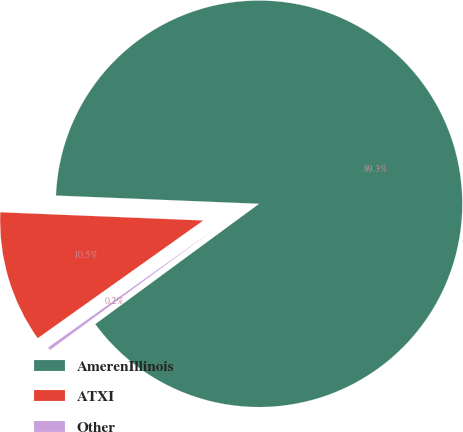Convert chart to OTSL. <chart><loc_0><loc_0><loc_500><loc_500><pie_chart><fcel>AmerenIllinois<fcel>ATXI<fcel>Other<nl><fcel>89.27%<fcel>10.48%<fcel>0.25%<nl></chart> 